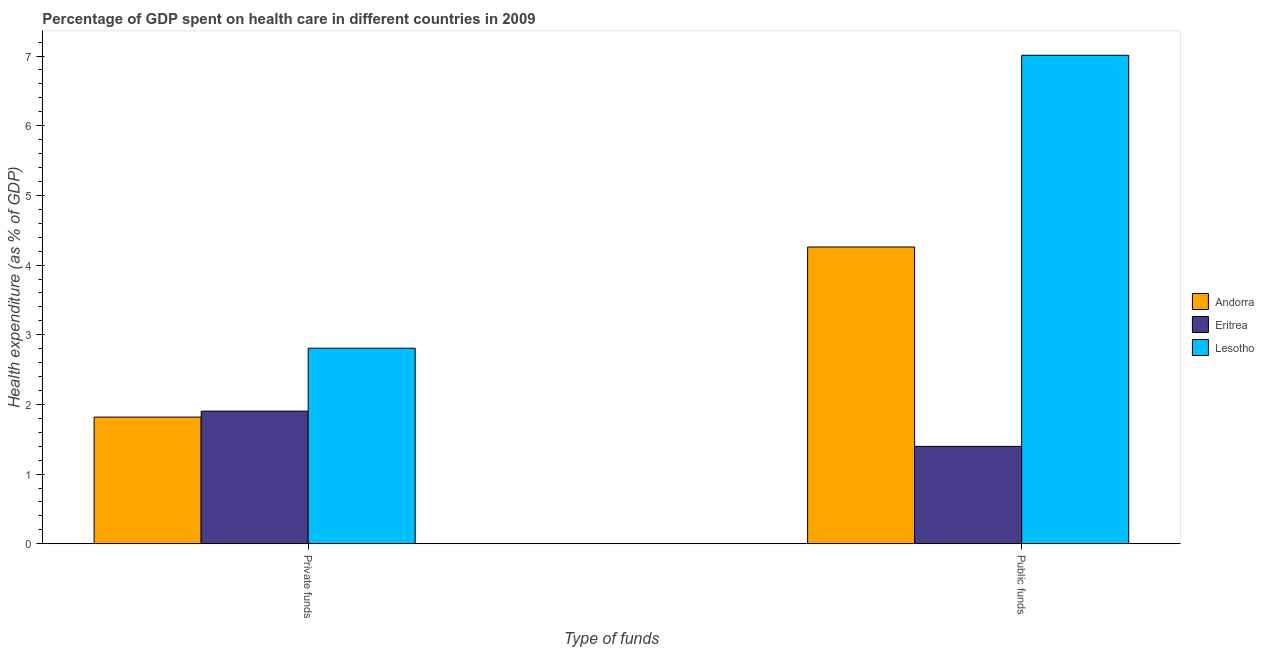How many different coloured bars are there?
Your response must be concise. 3. How many groups of bars are there?
Ensure brevity in your answer.  2. Are the number of bars per tick equal to the number of legend labels?
Your answer should be compact. Yes. Are the number of bars on each tick of the X-axis equal?
Your answer should be compact. Yes. How many bars are there on the 1st tick from the left?
Your answer should be compact. 3. What is the label of the 2nd group of bars from the left?
Your answer should be very brief. Public funds. What is the amount of private funds spent in healthcare in Eritrea?
Keep it short and to the point. 1.9. Across all countries, what is the maximum amount of public funds spent in healthcare?
Offer a terse response. 7.01. Across all countries, what is the minimum amount of private funds spent in healthcare?
Your answer should be very brief. 1.82. In which country was the amount of private funds spent in healthcare maximum?
Your answer should be very brief. Lesotho. In which country was the amount of private funds spent in healthcare minimum?
Keep it short and to the point. Andorra. What is the total amount of private funds spent in healthcare in the graph?
Provide a succinct answer. 6.53. What is the difference between the amount of public funds spent in healthcare in Eritrea and that in Andorra?
Keep it short and to the point. -2.86. What is the difference between the amount of public funds spent in healthcare in Andorra and the amount of private funds spent in healthcare in Eritrea?
Provide a succinct answer. 2.36. What is the average amount of private funds spent in healthcare per country?
Make the answer very short. 2.18. What is the difference between the amount of private funds spent in healthcare and amount of public funds spent in healthcare in Lesotho?
Keep it short and to the point. -4.2. What is the ratio of the amount of public funds spent in healthcare in Eritrea to that in Andorra?
Make the answer very short. 0.33. In how many countries, is the amount of private funds spent in healthcare greater than the average amount of private funds spent in healthcare taken over all countries?
Offer a terse response. 1. What does the 1st bar from the left in Private funds represents?
Offer a very short reply. Andorra. What does the 3rd bar from the right in Private funds represents?
Make the answer very short. Andorra. How many bars are there?
Your answer should be very brief. 6. Are all the bars in the graph horizontal?
Give a very brief answer. No. What is the difference between two consecutive major ticks on the Y-axis?
Your answer should be very brief. 1. Where does the legend appear in the graph?
Your response must be concise. Center right. How many legend labels are there?
Your response must be concise. 3. How are the legend labels stacked?
Keep it short and to the point. Vertical. What is the title of the graph?
Offer a terse response. Percentage of GDP spent on health care in different countries in 2009. What is the label or title of the X-axis?
Keep it short and to the point. Type of funds. What is the label or title of the Y-axis?
Provide a succinct answer. Health expenditure (as % of GDP). What is the Health expenditure (as % of GDP) of Andorra in Private funds?
Provide a succinct answer. 1.82. What is the Health expenditure (as % of GDP) in Eritrea in Private funds?
Your response must be concise. 1.9. What is the Health expenditure (as % of GDP) in Lesotho in Private funds?
Your response must be concise. 2.81. What is the Health expenditure (as % of GDP) in Andorra in Public funds?
Give a very brief answer. 4.26. What is the Health expenditure (as % of GDP) of Eritrea in Public funds?
Your answer should be very brief. 1.4. What is the Health expenditure (as % of GDP) in Lesotho in Public funds?
Your response must be concise. 7.01. Across all Type of funds, what is the maximum Health expenditure (as % of GDP) of Andorra?
Offer a terse response. 4.26. Across all Type of funds, what is the maximum Health expenditure (as % of GDP) of Eritrea?
Your response must be concise. 1.9. Across all Type of funds, what is the maximum Health expenditure (as % of GDP) of Lesotho?
Keep it short and to the point. 7.01. Across all Type of funds, what is the minimum Health expenditure (as % of GDP) in Andorra?
Offer a terse response. 1.82. Across all Type of funds, what is the minimum Health expenditure (as % of GDP) of Eritrea?
Offer a terse response. 1.4. Across all Type of funds, what is the minimum Health expenditure (as % of GDP) in Lesotho?
Offer a terse response. 2.81. What is the total Health expenditure (as % of GDP) of Andorra in the graph?
Ensure brevity in your answer.  6.08. What is the total Health expenditure (as % of GDP) in Eritrea in the graph?
Your answer should be compact. 3.3. What is the total Health expenditure (as % of GDP) of Lesotho in the graph?
Provide a short and direct response. 9.82. What is the difference between the Health expenditure (as % of GDP) in Andorra in Private funds and that in Public funds?
Give a very brief answer. -2.44. What is the difference between the Health expenditure (as % of GDP) in Eritrea in Private funds and that in Public funds?
Your answer should be very brief. 0.51. What is the difference between the Health expenditure (as % of GDP) in Lesotho in Private funds and that in Public funds?
Your answer should be very brief. -4.2. What is the difference between the Health expenditure (as % of GDP) of Andorra in Private funds and the Health expenditure (as % of GDP) of Eritrea in Public funds?
Your answer should be very brief. 0.42. What is the difference between the Health expenditure (as % of GDP) in Andorra in Private funds and the Health expenditure (as % of GDP) in Lesotho in Public funds?
Provide a succinct answer. -5.19. What is the difference between the Health expenditure (as % of GDP) in Eritrea in Private funds and the Health expenditure (as % of GDP) in Lesotho in Public funds?
Your response must be concise. -5.11. What is the average Health expenditure (as % of GDP) of Andorra per Type of funds?
Offer a very short reply. 3.04. What is the average Health expenditure (as % of GDP) in Eritrea per Type of funds?
Your response must be concise. 1.65. What is the average Health expenditure (as % of GDP) of Lesotho per Type of funds?
Make the answer very short. 4.91. What is the difference between the Health expenditure (as % of GDP) of Andorra and Health expenditure (as % of GDP) of Eritrea in Private funds?
Ensure brevity in your answer.  -0.09. What is the difference between the Health expenditure (as % of GDP) of Andorra and Health expenditure (as % of GDP) of Lesotho in Private funds?
Give a very brief answer. -0.99. What is the difference between the Health expenditure (as % of GDP) of Eritrea and Health expenditure (as % of GDP) of Lesotho in Private funds?
Your answer should be very brief. -0.9. What is the difference between the Health expenditure (as % of GDP) in Andorra and Health expenditure (as % of GDP) in Eritrea in Public funds?
Ensure brevity in your answer.  2.86. What is the difference between the Health expenditure (as % of GDP) of Andorra and Health expenditure (as % of GDP) of Lesotho in Public funds?
Ensure brevity in your answer.  -2.75. What is the difference between the Health expenditure (as % of GDP) in Eritrea and Health expenditure (as % of GDP) in Lesotho in Public funds?
Ensure brevity in your answer.  -5.61. What is the ratio of the Health expenditure (as % of GDP) in Andorra in Private funds to that in Public funds?
Make the answer very short. 0.43. What is the ratio of the Health expenditure (as % of GDP) of Eritrea in Private funds to that in Public funds?
Provide a short and direct response. 1.36. What is the ratio of the Health expenditure (as % of GDP) of Lesotho in Private funds to that in Public funds?
Provide a succinct answer. 0.4. What is the difference between the highest and the second highest Health expenditure (as % of GDP) in Andorra?
Your answer should be compact. 2.44. What is the difference between the highest and the second highest Health expenditure (as % of GDP) in Eritrea?
Keep it short and to the point. 0.51. What is the difference between the highest and the second highest Health expenditure (as % of GDP) in Lesotho?
Ensure brevity in your answer.  4.2. What is the difference between the highest and the lowest Health expenditure (as % of GDP) in Andorra?
Your answer should be very brief. 2.44. What is the difference between the highest and the lowest Health expenditure (as % of GDP) of Eritrea?
Make the answer very short. 0.51. What is the difference between the highest and the lowest Health expenditure (as % of GDP) of Lesotho?
Ensure brevity in your answer.  4.2. 